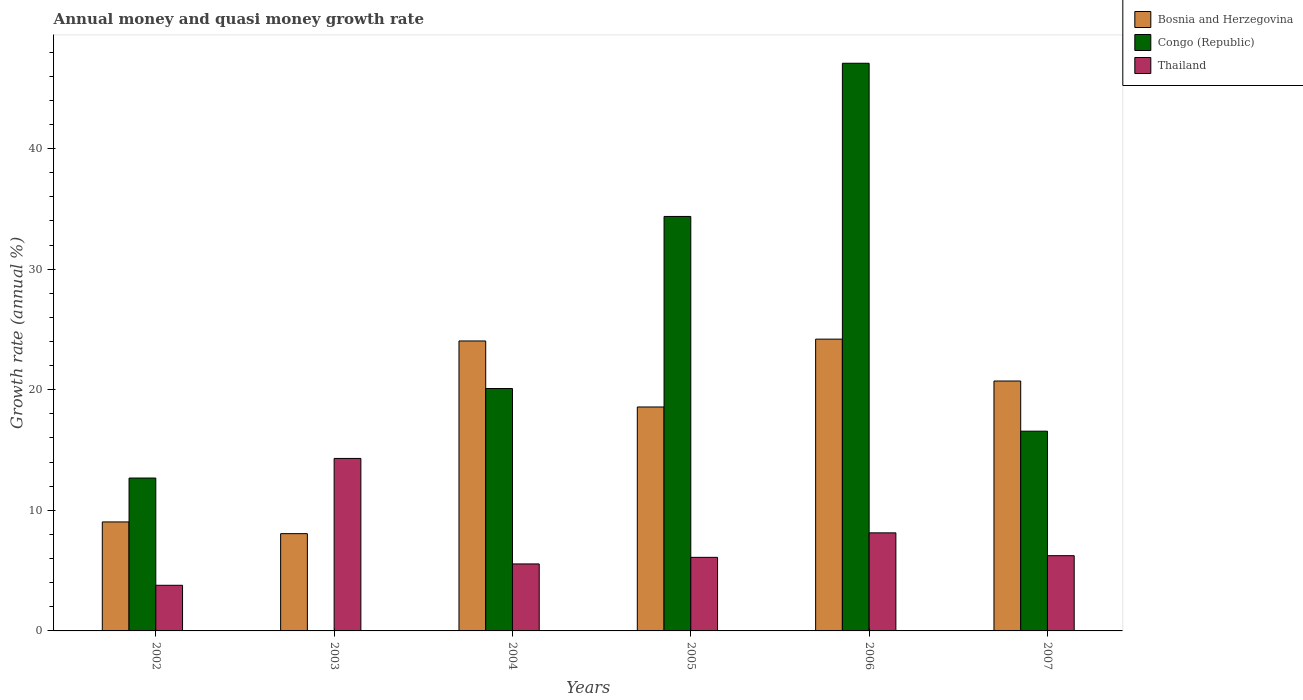How many groups of bars are there?
Make the answer very short. 6. Are the number of bars per tick equal to the number of legend labels?
Your answer should be very brief. No. How many bars are there on the 6th tick from the left?
Offer a terse response. 3. What is the label of the 1st group of bars from the left?
Your answer should be very brief. 2002. Across all years, what is the maximum growth rate in Bosnia and Herzegovina?
Provide a short and direct response. 24.2. Across all years, what is the minimum growth rate in Thailand?
Keep it short and to the point. 3.78. What is the total growth rate in Thailand in the graph?
Offer a very short reply. 44.12. What is the difference between the growth rate in Congo (Republic) in 2002 and that in 2005?
Provide a succinct answer. -21.69. What is the difference between the growth rate in Congo (Republic) in 2006 and the growth rate in Bosnia and Herzegovina in 2004?
Your response must be concise. 23.03. What is the average growth rate in Congo (Republic) per year?
Your response must be concise. 21.8. In the year 2002, what is the difference between the growth rate in Thailand and growth rate in Bosnia and Herzegovina?
Give a very brief answer. -5.25. What is the ratio of the growth rate in Thailand in 2002 to that in 2004?
Offer a very short reply. 0.68. Is the growth rate in Congo (Republic) in 2002 less than that in 2007?
Offer a terse response. Yes. Is the difference between the growth rate in Thailand in 2003 and 2007 greater than the difference between the growth rate in Bosnia and Herzegovina in 2003 and 2007?
Make the answer very short. Yes. What is the difference between the highest and the second highest growth rate in Bosnia and Herzegovina?
Provide a succinct answer. 0.15. What is the difference between the highest and the lowest growth rate in Bosnia and Herzegovina?
Make the answer very short. 16.13. Is the sum of the growth rate in Congo (Republic) in 2006 and 2007 greater than the maximum growth rate in Bosnia and Herzegovina across all years?
Make the answer very short. Yes. Is it the case that in every year, the sum of the growth rate in Congo (Republic) and growth rate in Bosnia and Herzegovina is greater than the growth rate in Thailand?
Give a very brief answer. No. How many bars are there?
Your answer should be very brief. 17. Are all the bars in the graph horizontal?
Your answer should be very brief. No. How many years are there in the graph?
Keep it short and to the point. 6. Are the values on the major ticks of Y-axis written in scientific E-notation?
Your answer should be compact. No. Does the graph contain any zero values?
Keep it short and to the point. Yes. Where does the legend appear in the graph?
Provide a short and direct response. Top right. How are the legend labels stacked?
Give a very brief answer. Vertical. What is the title of the graph?
Offer a very short reply. Annual money and quasi money growth rate. What is the label or title of the Y-axis?
Your answer should be very brief. Growth rate (annual %). What is the Growth rate (annual %) of Bosnia and Herzegovina in 2002?
Your answer should be compact. 9.04. What is the Growth rate (annual %) of Congo (Republic) in 2002?
Your answer should be compact. 12.68. What is the Growth rate (annual %) of Thailand in 2002?
Make the answer very short. 3.78. What is the Growth rate (annual %) of Bosnia and Herzegovina in 2003?
Your answer should be very brief. 8.07. What is the Growth rate (annual %) of Thailand in 2003?
Provide a succinct answer. 14.3. What is the Growth rate (annual %) of Bosnia and Herzegovina in 2004?
Offer a terse response. 24.05. What is the Growth rate (annual %) in Congo (Republic) in 2004?
Your answer should be very brief. 20.1. What is the Growth rate (annual %) of Thailand in 2004?
Your answer should be compact. 5.56. What is the Growth rate (annual %) of Bosnia and Herzegovina in 2005?
Your answer should be very brief. 18.57. What is the Growth rate (annual %) of Congo (Republic) in 2005?
Your answer should be very brief. 34.37. What is the Growth rate (annual %) in Thailand in 2005?
Provide a succinct answer. 6.1. What is the Growth rate (annual %) in Bosnia and Herzegovina in 2006?
Give a very brief answer. 24.2. What is the Growth rate (annual %) in Congo (Republic) in 2006?
Give a very brief answer. 47.08. What is the Growth rate (annual %) of Thailand in 2006?
Your response must be concise. 8.13. What is the Growth rate (annual %) of Bosnia and Herzegovina in 2007?
Make the answer very short. 20.72. What is the Growth rate (annual %) in Congo (Republic) in 2007?
Give a very brief answer. 16.56. What is the Growth rate (annual %) of Thailand in 2007?
Ensure brevity in your answer.  6.24. Across all years, what is the maximum Growth rate (annual %) of Bosnia and Herzegovina?
Keep it short and to the point. 24.2. Across all years, what is the maximum Growth rate (annual %) of Congo (Republic)?
Provide a succinct answer. 47.08. Across all years, what is the maximum Growth rate (annual %) of Thailand?
Make the answer very short. 14.3. Across all years, what is the minimum Growth rate (annual %) in Bosnia and Herzegovina?
Ensure brevity in your answer.  8.07. Across all years, what is the minimum Growth rate (annual %) in Thailand?
Provide a succinct answer. 3.78. What is the total Growth rate (annual %) in Bosnia and Herzegovina in the graph?
Provide a succinct answer. 104.64. What is the total Growth rate (annual %) in Congo (Republic) in the graph?
Provide a short and direct response. 130.79. What is the total Growth rate (annual %) in Thailand in the graph?
Provide a short and direct response. 44.12. What is the difference between the Growth rate (annual %) in Bosnia and Herzegovina in 2002 and that in 2003?
Your answer should be very brief. 0.97. What is the difference between the Growth rate (annual %) in Thailand in 2002 and that in 2003?
Provide a succinct answer. -10.52. What is the difference between the Growth rate (annual %) in Bosnia and Herzegovina in 2002 and that in 2004?
Make the answer very short. -15.01. What is the difference between the Growth rate (annual %) of Congo (Republic) in 2002 and that in 2004?
Give a very brief answer. -7.42. What is the difference between the Growth rate (annual %) of Thailand in 2002 and that in 2004?
Make the answer very short. -1.77. What is the difference between the Growth rate (annual %) of Bosnia and Herzegovina in 2002 and that in 2005?
Your answer should be very brief. -9.53. What is the difference between the Growth rate (annual %) in Congo (Republic) in 2002 and that in 2005?
Provide a short and direct response. -21.69. What is the difference between the Growth rate (annual %) of Thailand in 2002 and that in 2005?
Offer a terse response. -2.32. What is the difference between the Growth rate (annual %) of Bosnia and Herzegovina in 2002 and that in 2006?
Make the answer very short. -15.16. What is the difference between the Growth rate (annual %) of Congo (Republic) in 2002 and that in 2006?
Provide a succinct answer. -34.4. What is the difference between the Growth rate (annual %) in Thailand in 2002 and that in 2006?
Your response must be concise. -4.35. What is the difference between the Growth rate (annual %) of Bosnia and Herzegovina in 2002 and that in 2007?
Your answer should be compact. -11.69. What is the difference between the Growth rate (annual %) in Congo (Republic) in 2002 and that in 2007?
Your answer should be compact. -3.89. What is the difference between the Growth rate (annual %) in Thailand in 2002 and that in 2007?
Provide a succinct answer. -2.45. What is the difference between the Growth rate (annual %) of Bosnia and Herzegovina in 2003 and that in 2004?
Offer a very short reply. -15.98. What is the difference between the Growth rate (annual %) in Thailand in 2003 and that in 2004?
Offer a terse response. 8.75. What is the difference between the Growth rate (annual %) of Bosnia and Herzegovina in 2003 and that in 2005?
Keep it short and to the point. -10.5. What is the difference between the Growth rate (annual %) in Thailand in 2003 and that in 2005?
Provide a succinct answer. 8.2. What is the difference between the Growth rate (annual %) in Bosnia and Herzegovina in 2003 and that in 2006?
Keep it short and to the point. -16.13. What is the difference between the Growth rate (annual %) in Thailand in 2003 and that in 2006?
Your answer should be very brief. 6.17. What is the difference between the Growth rate (annual %) in Bosnia and Herzegovina in 2003 and that in 2007?
Keep it short and to the point. -12.66. What is the difference between the Growth rate (annual %) of Thailand in 2003 and that in 2007?
Provide a short and direct response. 8.06. What is the difference between the Growth rate (annual %) of Bosnia and Herzegovina in 2004 and that in 2005?
Your answer should be compact. 5.48. What is the difference between the Growth rate (annual %) of Congo (Republic) in 2004 and that in 2005?
Offer a terse response. -14.27. What is the difference between the Growth rate (annual %) of Thailand in 2004 and that in 2005?
Give a very brief answer. -0.55. What is the difference between the Growth rate (annual %) of Bosnia and Herzegovina in 2004 and that in 2006?
Ensure brevity in your answer.  -0.15. What is the difference between the Growth rate (annual %) of Congo (Republic) in 2004 and that in 2006?
Offer a very short reply. -26.97. What is the difference between the Growth rate (annual %) in Thailand in 2004 and that in 2006?
Offer a very short reply. -2.58. What is the difference between the Growth rate (annual %) in Bosnia and Herzegovina in 2004 and that in 2007?
Keep it short and to the point. 3.32. What is the difference between the Growth rate (annual %) in Congo (Republic) in 2004 and that in 2007?
Your answer should be very brief. 3.54. What is the difference between the Growth rate (annual %) of Thailand in 2004 and that in 2007?
Your answer should be compact. -0.68. What is the difference between the Growth rate (annual %) in Bosnia and Herzegovina in 2005 and that in 2006?
Make the answer very short. -5.63. What is the difference between the Growth rate (annual %) of Congo (Republic) in 2005 and that in 2006?
Offer a very short reply. -12.7. What is the difference between the Growth rate (annual %) in Thailand in 2005 and that in 2006?
Your answer should be very brief. -2.03. What is the difference between the Growth rate (annual %) in Bosnia and Herzegovina in 2005 and that in 2007?
Your answer should be very brief. -2.15. What is the difference between the Growth rate (annual %) in Congo (Republic) in 2005 and that in 2007?
Your response must be concise. 17.81. What is the difference between the Growth rate (annual %) in Thailand in 2005 and that in 2007?
Give a very brief answer. -0.14. What is the difference between the Growth rate (annual %) of Bosnia and Herzegovina in 2006 and that in 2007?
Keep it short and to the point. 3.47. What is the difference between the Growth rate (annual %) in Congo (Republic) in 2006 and that in 2007?
Offer a very short reply. 30.51. What is the difference between the Growth rate (annual %) of Thailand in 2006 and that in 2007?
Make the answer very short. 1.89. What is the difference between the Growth rate (annual %) of Bosnia and Herzegovina in 2002 and the Growth rate (annual %) of Thailand in 2003?
Keep it short and to the point. -5.27. What is the difference between the Growth rate (annual %) in Congo (Republic) in 2002 and the Growth rate (annual %) in Thailand in 2003?
Provide a succinct answer. -1.63. What is the difference between the Growth rate (annual %) in Bosnia and Herzegovina in 2002 and the Growth rate (annual %) in Congo (Republic) in 2004?
Provide a short and direct response. -11.06. What is the difference between the Growth rate (annual %) in Bosnia and Herzegovina in 2002 and the Growth rate (annual %) in Thailand in 2004?
Your answer should be compact. 3.48. What is the difference between the Growth rate (annual %) of Congo (Republic) in 2002 and the Growth rate (annual %) of Thailand in 2004?
Provide a succinct answer. 7.12. What is the difference between the Growth rate (annual %) in Bosnia and Herzegovina in 2002 and the Growth rate (annual %) in Congo (Republic) in 2005?
Ensure brevity in your answer.  -25.33. What is the difference between the Growth rate (annual %) of Bosnia and Herzegovina in 2002 and the Growth rate (annual %) of Thailand in 2005?
Offer a very short reply. 2.94. What is the difference between the Growth rate (annual %) in Congo (Republic) in 2002 and the Growth rate (annual %) in Thailand in 2005?
Provide a succinct answer. 6.58. What is the difference between the Growth rate (annual %) of Bosnia and Herzegovina in 2002 and the Growth rate (annual %) of Congo (Republic) in 2006?
Keep it short and to the point. -38.04. What is the difference between the Growth rate (annual %) of Bosnia and Herzegovina in 2002 and the Growth rate (annual %) of Thailand in 2006?
Provide a succinct answer. 0.91. What is the difference between the Growth rate (annual %) in Congo (Republic) in 2002 and the Growth rate (annual %) in Thailand in 2006?
Your answer should be compact. 4.55. What is the difference between the Growth rate (annual %) of Bosnia and Herzegovina in 2002 and the Growth rate (annual %) of Congo (Republic) in 2007?
Make the answer very short. -7.53. What is the difference between the Growth rate (annual %) of Bosnia and Herzegovina in 2002 and the Growth rate (annual %) of Thailand in 2007?
Your answer should be compact. 2.8. What is the difference between the Growth rate (annual %) in Congo (Republic) in 2002 and the Growth rate (annual %) in Thailand in 2007?
Provide a succinct answer. 6.44. What is the difference between the Growth rate (annual %) of Bosnia and Herzegovina in 2003 and the Growth rate (annual %) of Congo (Republic) in 2004?
Ensure brevity in your answer.  -12.03. What is the difference between the Growth rate (annual %) of Bosnia and Herzegovina in 2003 and the Growth rate (annual %) of Thailand in 2004?
Provide a succinct answer. 2.51. What is the difference between the Growth rate (annual %) in Bosnia and Herzegovina in 2003 and the Growth rate (annual %) in Congo (Republic) in 2005?
Provide a short and direct response. -26.31. What is the difference between the Growth rate (annual %) in Bosnia and Herzegovina in 2003 and the Growth rate (annual %) in Thailand in 2005?
Keep it short and to the point. 1.97. What is the difference between the Growth rate (annual %) in Bosnia and Herzegovina in 2003 and the Growth rate (annual %) in Congo (Republic) in 2006?
Provide a short and direct response. -39.01. What is the difference between the Growth rate (annual %) of Bosnia and Herzegovina in 2003 and the Growth rate (annual %) of Thailand in 2006?
Give a very brief answer. -0.07. What is the difference between the Growth rate (annual %) of Bosnia and Herzegovina in 2003 and the Growth rate (annual %) of Congo (Republic) in 2007?
Offer a terse response. -8.5. What is the difference between the Growth rate (annual %) in Bosnia and Herzegovina in 2003 and the Growth rate (annual %) in Thailand in 2007?
Your answer should be compact. 1.83. What is the difference between the Growth rate (annual %) of Bosnia and Herzegovina in 2004 and the Growth rate (annual %) of Congo (Republic) in 2005?
Provide a short and direct response. -10.33. What is the difference between the Growth rate (annual %) of Bosnia and Herzegovina in 2004 and the Growth rate (annual %) of Thailand in 2005?
Give a very brief answer. 17.94. What is the difference between the Growth rate (annual %) in Congo (Republic) in 2004 and the Growth rate (annual %) in Thailand in 2005?
Your answer should be very brief. 14. What is the difference between the Growth rate (annual %) in Bosnia and Herzegovina in 2004 and the Growth rate (annual %) in Congo (Republic) in 2006?
Your answer should be compact. -23.03. What is the difference between the Growth rate (annual %) of Bosnia and Herzegovina in 2004 and the Growth rate (annual %) of Thailand in 2006?
Make the answer very short. 15.91. What is the difference between the Growth rate (annual %) in Congo (Republic) in 2004 and the Growth rate (annual %) in Thailand in 2006?
Your answer should be very brief. 11.97. What is the difference between the Growth rate (annual %) of Bosnia and Herzegovina in 2004 and the Growth rate (annual %) of Congo (Republic) in 2007?
Provide a short and direct response. 7.48. What is the difference between the Growth rate (annual %) of Bosnia and Herzegovina in 2004 and the Growth rate (annual %) of Thailand in 2007?
Make the answer very short. 17.81. What is the difference between the Growth rate (annual %) of Congo (Republic) in 2004 and the Growth rate (annual %) of Thailand in 2007?
Your answer should be compact. 13.86. What is the difference between the Growth rate (annual %) in Bosnia and Herzegovina in 2005 and the Growth rate (annual %) in Congo (Republic) in 2006?
Provide a short and direct response. -28.5. What is the difference between the Growth rate (annual %) of Bosnia and Herzegovina in 2005 and the Growth rate (annual %) of Thailand in 2006?
Your response must be concise. 10.44. What is the difference between the Growth rate (annual %) of Congo (Republic) in 2005 and the Growth rate (annual %) of Thailand in 2006?
Offer a terse response. 26.24. What is the difference between the Growth rate (annual %) in Bosnia and Herzegovina in 2005 and the Growth rate (annual %) in Congo (Republic) in 2007?
Keep it short and to the point. 2.01. What is the difference between the Growth rate (annual %) in Bosnia and Herzegovina in 2005 and the Growth rate (annual %) in Thailand in 2007?
Offer a terse response. 12.33. What is the difference between the Growth rate (annual %) of Congo (Republic) in 2005 and the Growth rate (annual %) of Thailand in 2007?
Provide a short and direct response. 28.13. What is the difference between the Growth rate (annual %) of Bosnia and Herzegovina in 2006 and the Growth rate (annual %) of Congo (Republic) in 2007?
Offer a terse response. 7.63. What is the difference between the Growth rate (annual %) of Bosnia and Herzegovina in 2006 and the Growth rate (annual %) of Thailand in 2007?
Your answer should be compact. 17.96. What is the difference between the Growth rate (annual %) in Congo (Republic) in 2006 and the Growth rate (annual %) in Thailand in 2007?
Your response must be concise. 40.84. What is the average Growth rate (annual %) of Bosnia and Herzegovina per year?
Your response must be concise. 17.44. What is the average Growth rate (annual %) of Congo (Republic) per year?
Your answer should be very brief. 21.8. What is the average Growth rate (annual %) in Thailand per year?
Give a very brief answer. 7.35. In the year 2002, what is the difference between the Growth rate (annual %) of Bosnia and Herzegovina and Growth rate (annual %) of Congo (Republic)?
Your response must be concise. -3.64. In the year 2002, what is the difference between the Growth rate (annual %) of Bosnia and Herzegovina and Growth rate (annual %) of Thailand?
Your response must be concise. 5.25. In the year 2002, what is the difference between the Growth rate (annual %) of Congo (Republic) and Growth rate (annual %) of Thailand?
Ensure brevity in your answer.  8.89. In the year 2003, what is the difference between the Growth rate (annual %) of Bosnia and Herzegovina and Growth rate (annual %) of Thailand?
Ensure brevity in your answer.  -6.24. In the year 2004, what is the difference between the Growth rate (annual %) in Bosnia and Herzegovina and Growth rate (annual %) in Congo (Republic)?
Your answer should be very brief. 3.94. In the year 2004, what is the difference between the Growth rate (annual %) of Bosnia and Herzegovina and Growth rate (annual %) of Thailand?
Offer a very short reply. 18.49. In the year 2004, what is the difference between the Growth rate (annual %) of Congo (Republic) and Growth rate (annual %) of Thailand?
Your response must be concise. 14.55. In the year 2005, what is the difference between the Growth rate (annual %) in Bosnia and Herzegovina and Growth rate (annual %) in Congo (Republic)?
Offer a very short reply. -15.8. In the year 2005, what is the difference between the Growth rate (annual %) in Bosnia and Herzegovina and Growth rate (annual %) in Thailand?
Your answer should be very brief. 12.47. In the year 2005, what is the difference between the Growth rate (annual %) of Congo (Republic) and Growth rate (annual %) of Thailand?
Give a very brief answer. 28.27. In the year 2006, what is the difference between the Growth rate (annual %) of Bosnia and Herzegovina and Growth rate (annual %) of Congo (Republic)?
Provide a short and direct response. -22.88. In the year 2006, what is the difference between the Growth rate (annual %) in Bosnia and Herzegovina and Growth rate (annual %) in Thailand?
Your response must be concise. 16.07. In the year 2006, what is the difference between the Growth rate (annual %) of Congo (Republic) and Growth rate (annual %) of Thailand?
Make the answer very short. 38.94. In the year 2007, what is the difference between the Growth rate (annual %) in Bosnia and Herzegovina and Growth rate (annual %) in Congo (Republic)?
Your answer should be compact. 4.16. In the year 2007, what is the difference between the Growth rate (annual %) of Bosnia and Herzegovina and Growth rate (annual %) of Thailand?
Provide a short and direct response. 14.49. In the year 2007, what is the difference between the Growth rate (annual %) of Congo (Republic) and Growth rate (annual %) of Thailand?
Offer a very short reply. 10.32. What is the ratio of the Growth rate (annual %) in Bosnia and Herzegovina in 2002 to that in 2003?
Offer a very short reply. 1.12. What is the ratio of the Growth rate (annual %) in Thailand in 2002 to that in 2003?
Make the answer very short. 0.26. What is the ratio of the Growth rate (annual %) of Bosnia and Herzegovina in 2002 to that in 2004?
Your response must be concise. 0.38. What is the ratio of the Growth rate (annual %) of Congo (Republic) in 2002 to that in 2004?
Your answer should be very brief. 0.63. What is the ratio of the Growth rate (annual %) in Thailand in 2002 to that in 2004?
Keep it short and to the point. 0.68. What is the ratio of the Growth rate (annual %) of Bosnia and Herzegovina in 2002 to that in 2005?
Ensure brevity in your answer.  0.49. What is the ratio of the Growth rate (annual %) in Congo (Republic) in 2002 to that in 2005?
Give a very brief answer. 0.37. What is the ratio of the Growth rate (annual %) of Thailand in 2002 to that in 2005?
Your response must be concise. 0.62. What is the ratio of the Growth rate (annual %) of Bosnia and Herzegovina in 2002 to that in 2006?
Provide a short and direct response. 0.37. What is the ratio of the Growth rate (annual %) of Congo (Republic) in 2002 to that in 2006?
Your answer should be very brief. 0.27. What is the ratio of the Growth rate (annual %) of Thailand in 2002 to that in 2006?
Keep it short and to the point. 0.47. What is the ratio of the Growth rate (annual %) of Bosnia and Herzegovina in 2002 to that in 2007?
Offer a terse response. 0.44. What is the ratio of the Growth rate (annual %) in Congo (Republic) in 2002 to that in 2007?
Provide a succinct answer. 0.77. What is the ratio of the Growth rate (annual %) of Thailand in 2002 to that in 2007?
Provide a short and direct response. 0.61. What is the ratio of the Growth rate (annual %) of Bosnia and Herzegovina in 2003 to that in 2004?
Make the answer very short. 0.34. What is the ratio of the Growth rate (annual %) in Thailand in 2003 to that in 2004?
Provide a short and direct response. 2.57. What is the ratio of the Growth rate (annual %) in Bosnia and Herzegovina in 2003 to that in 2005?
Give a very brief answer. 0.43. What is the ratio of the Growth rate (annual %) in Thailand in 2003 to that in 2005?
Your answer should be compact. 2.34. What is the ratio of the Growth rate (annual %) in Bosnia and Herzegovina in 2003 to that in 2006?
Provide a short and direct response. 0.33. What is the ratio of the Growth rate (annual %) of Thailand in 2003 to that in 2006?
Ensure brevity in your answer.  1.76. What is the ratio of the Growth rate (annual %) in Bosnia and Herzegovina in 2003 to that in 2007?
Your response must be concise. 0.39. What is the ratio of the Growth rate (annual %) of Thailand in 2003 to that in 2007?
Ensure brevity in your answer.  2.29. What is the ratio of the Growth rate (annual %) of Bosnia and Herzegovina in 2004 to that in 2005?
Ensure brevity in your answer.  1.29. What is the ratio of the Growth rate (annual %) in Congo (Republic) in 2004 to that in 2005?
Your answer should be compact. 0.58. What is the ratio of the Growth rate (annual %) of Thailand in 2004 to that in 2005?
Ensure brevity in your answer.  0.91. What is the ratio of the Growth rate (annual %) in Bosnia and Herzegovina in 2004 to that in 2006?
Offer a terse response. 0.99. What is the ratio of the Growth rate (annual %) in Congo (Republic) in 2004 to that in 2006?
Give a very brief answer. 0.43. What is the ratio of the Growth rate (annual %) of Thailand in 2004 to that in 2006?
Your response must be concise. 0.68. What is the ratio of the Growth rate (annual %) of Bosnia and Herzegovina in 2004 to that in 2007?
Your response must be concise. 1.16. What is the ratio of the Growth rate (annual %) of Congo (Republic) in 2004 to that in 2007?
Your answer should be very brief. 1.21. What is the ratio of the Growth rate (annual %) of Thailand in 2004 to that in 2007?
Make the answer very short. 0.89. What is the ratio of the Growth rate (annual %) of Bosnia and Herzegovina in 2005 to that in 2006?
Offer a terse response. 0.77. What is the ratio of the Growth rate (annual %) of Congo (Republic) in 2005 to that in 2006?
Provide a short and direct response. 0.73. What is the ratio of the Growth rate (annual %) of Thailand in 2005 to that in 2006?
Offer a very short reply. 0.75. What is the ratio of the Growth rate (annual %) of Bosnia and Herzegovina in 2005 to that in 2007?
Your response must be concise. 0.9. What is the ratio of the Growth rate (annual %) of Congo (Republic) in 2005 to that in 2007?
Offer a terse response. 2.08. What is the ratio of the Growth rate (annual %) in Thailand in 2005 to that in 2007?
Give a very brief answer. 0.98. What is the ratio of the Growth rate (annual %) of Bosnia and Herzegovina in 2006 to that in 2007?
Your response must be concise. 1.17. What is the ratio of the Growth rate (annual %) of Congo (Republic) in 2006 to that in 2007?
Your answer should be very brief. 2.84. What is the ratio of the Growth rate (annual %) in Thailand in 2006 to that in 2007?
Ensure brevity in your answer.  1.3. What is the difference between the highest and the second highest Growth rate (annual %) of Bosnia and Herzegovina?
Provide a short and direct response. 0.15. What is the difference between the highest and the second highest Growth rate (annual %) of Congo (Republic)?
Offer a very short reply. 12.7. What is the difference between the highest and the second highest Growth rate (annual %) of Thailand?
Offer a terse response. 6.17. What is the difference between the highest and the lowest Growth rate (annual %) of Bosnia and Herzegovina?
Your answer should be compact. 16.13. What is the difference between the highest and the lowest Growth rate (annual %) of Congo (Republic)?
Offer a terse response. 47.08. What is the difference between the highest and the lowest Growth rate (annual %) in Thailand?
Your response must be concise. 10.52. 